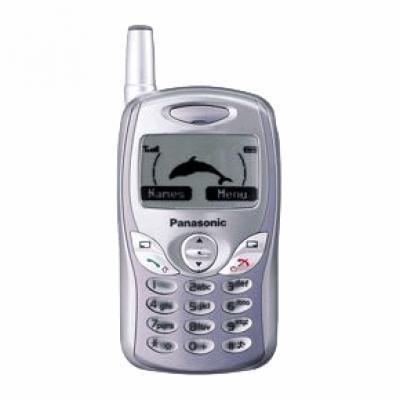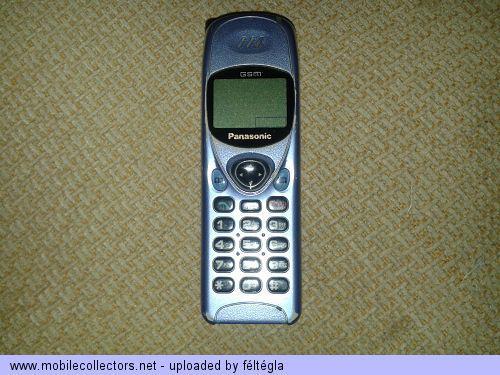The first image is the image on the left, the second image is the image on the right. Analyze the images presented: Is the assertion "Each image contains one narrow rectangular phone displayed vertically, with an antenna projecting from the top left of the phone." valid? Answer yes or no. No. The first image is the image on the left, the second image is the image on the right. Assess this claim about the two images: "In at least one image the is a single phone with a clear but blue button  in the middle of the phone representing 4 arrow keys.". Correct or not? Answer yes or no. No. 